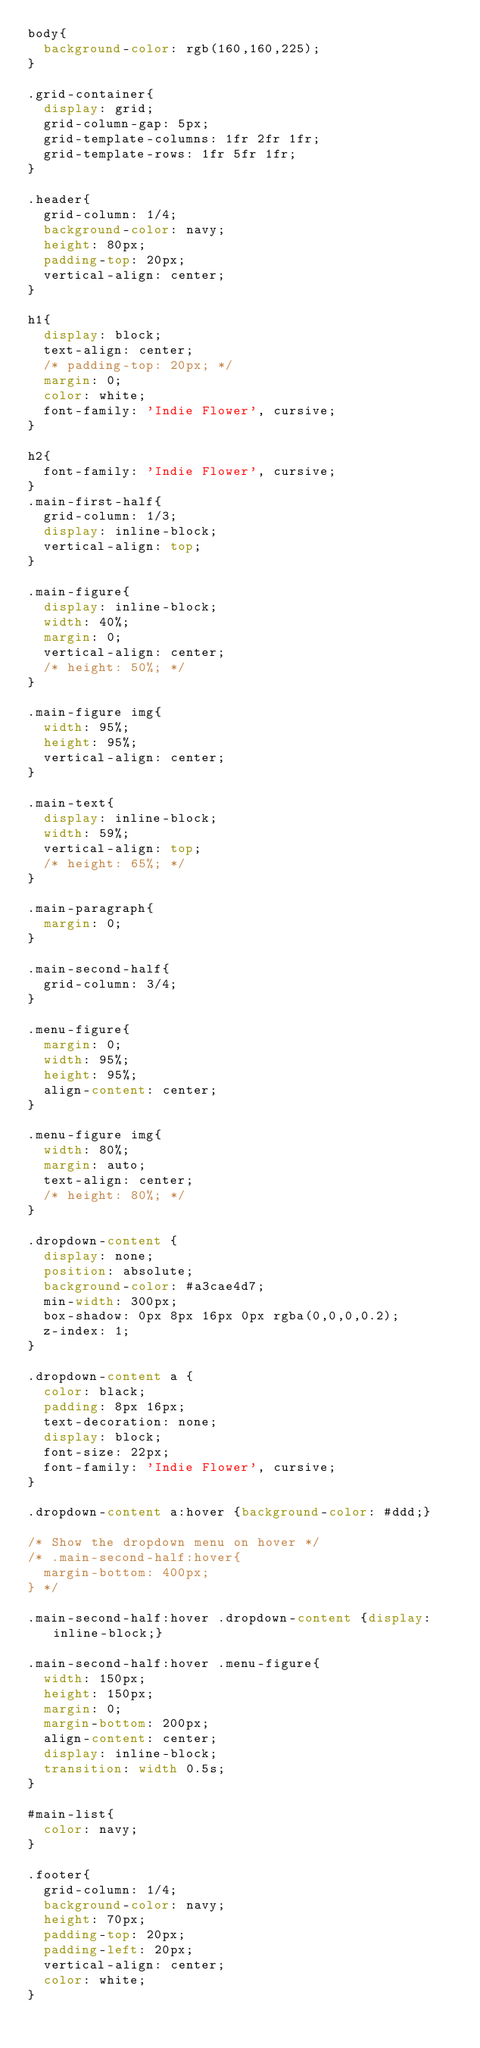Convert code to text. <code><loc_0><loc_0><loc_500><loc_500><_CSS_>body{
  background-color: rgb(160,160,225);
}

.grid-container{
  display: grid;
  grid-column-gap: 5px;
  grid-template-columns: 1fr 2fr 1fr;
  grid-template-rows: 1fr 5fr 1fr;
}

.header{
  grid-column: 1/4;
  background-color: navy;
  height: 80px;
  padding-top: 20px;
  vertical-align: center;
}

h1{
  display: block;
  text-align: center;
  /* padding-top: 20px; */
  margin: 0;
  color: white;
  font-family: 'Indie Flower', cursive;
}

h2{
  font-family: 'Indie Flower', cursive;
}
.main-first-half{
  grid-column: 1/3;
  display: inline-block;
  vertical-align: top;
}

.main-figure{
  display: inline-block;
  width: 40%;
  margin: 0;
  vertical-align: center;
  /* height: 50%; */
}

.main-figure img{
  width: 95%;
  height: 95%;
  vertical-align: center;
}

.main-text{
  display: inline-block;
  width: 59%;
  vertical-align: top;
  /* height: 65%; */
}

.main-paragraph{
  margin: 0;
}

.main-second-half{
  grid-column: 3/4;
}

.menu-figure{
  margin: 0;
  width: 95%;
  height: 95%;
  align-content: center;
}

.menu-figure img{
  width: 80%;
  margin: auto;
  text-align: center;
  /* height: 80%; */
}

.dropdown-content {
  display: none;
  position: absolute;
  background-color: #a3cae4d7;
  min-width: 300px;
  box-shadow: 0px 8px 16px 0px rgba(0,0,0,0.2);
  z-index: 1;
}

.dropdown-content a {
  color: black;
  padding: 8px 16px;
  text-decoration: none;
  display: block;
  font-size: 22px;
  font-family: 'Indie Flower', cursive;
}

.dropdown-content a:hover {background-color: #ddd;}

/* Show the dropdown menu on hover */
/* .main-second-half:hover{
  margin-bottom: 400px;
} */

.main-second-half:hover .dropdown-content {display: inline-block;}

.main-second-half:hover .menu-figure{
  width: 150px;
  height: 150px;
  margin: 0;
  margin-bottom: 200px;
  align-content: center;
  display: inline-block;
  transition: width 0.5s;
}

#main-list{
  color: navy;
}

.footer{
  grid-column: 1/4;
  background-color: navy;
  height: 70px;
  padding-top: 20px;
  padding-left: 20px;
  vertical-align: center;
  color: white;
}</code> 